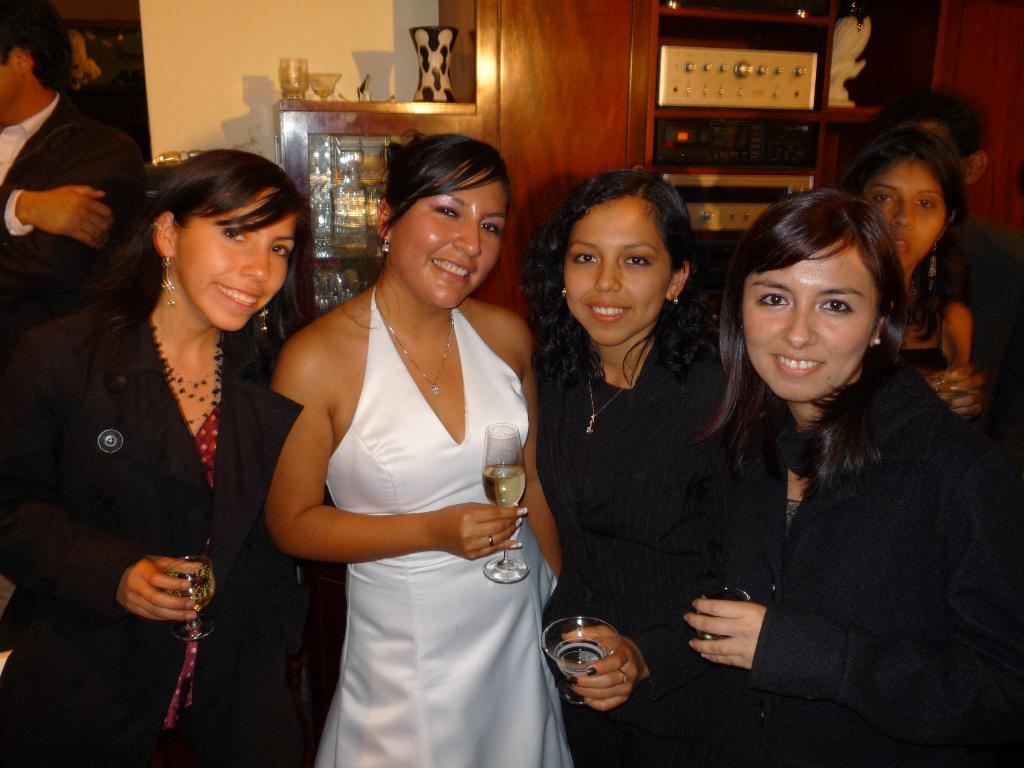How many people are in the group in the image? There is a group of people in the image, but the exact number is not specified. What are some people in the group holding? Some people in the group are holding glasses. What is behind the group of people? There is a wall behind the people. What can be seen on the shelves behind the people? There are objects in the shelves behind the people. What type of force is being applied to the objects on the page in the image? There is no page or force present in the image; it features a group of people with glasses and objects on shelves behind them. 